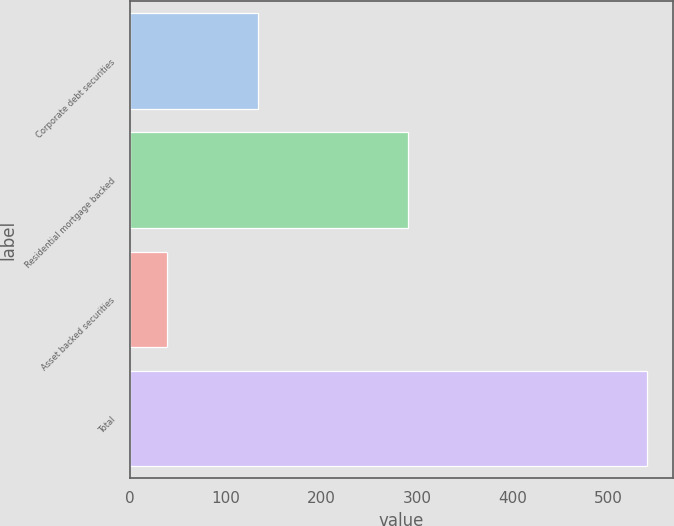Convert chart. <chart><loc_0><loc_0><loc_500><loc_500><bar_chart><fcel>Corporate debt securities<fcel>Residential mortgage backed<fcel>Asset backed securities<fcel>Total<nl><fcel>134<fcel>290<fcel>38<fcel>540<nl></chart> 